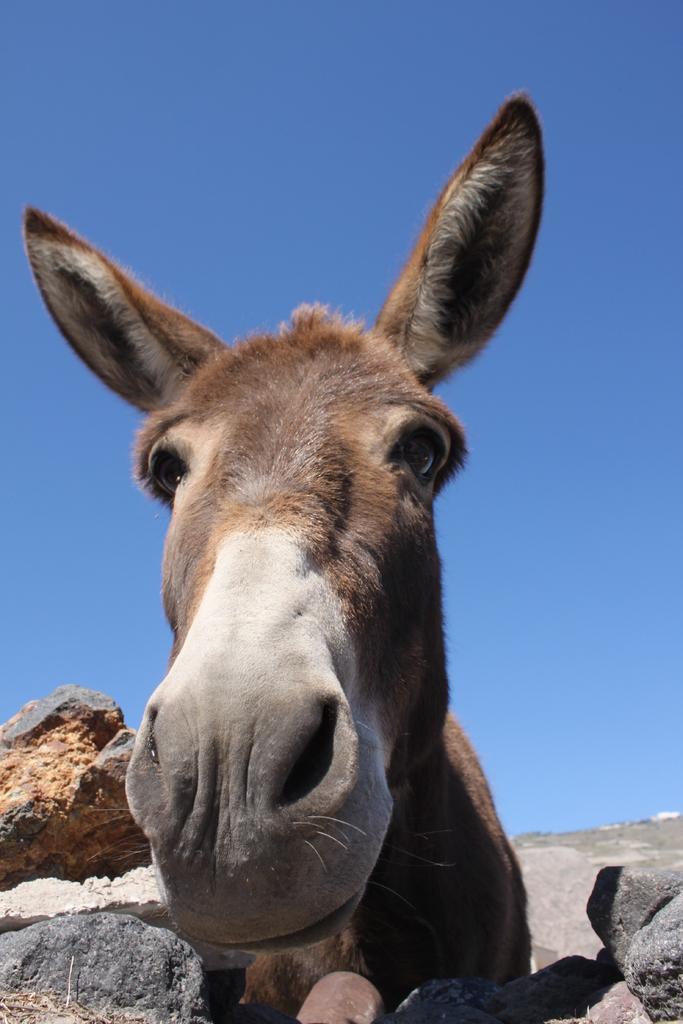How would you summarize this image in a sentence or two? In the center of the image we can see rocks and one donkey, which is in ash and brown color. In the background we can see the sky and a few other objects. 